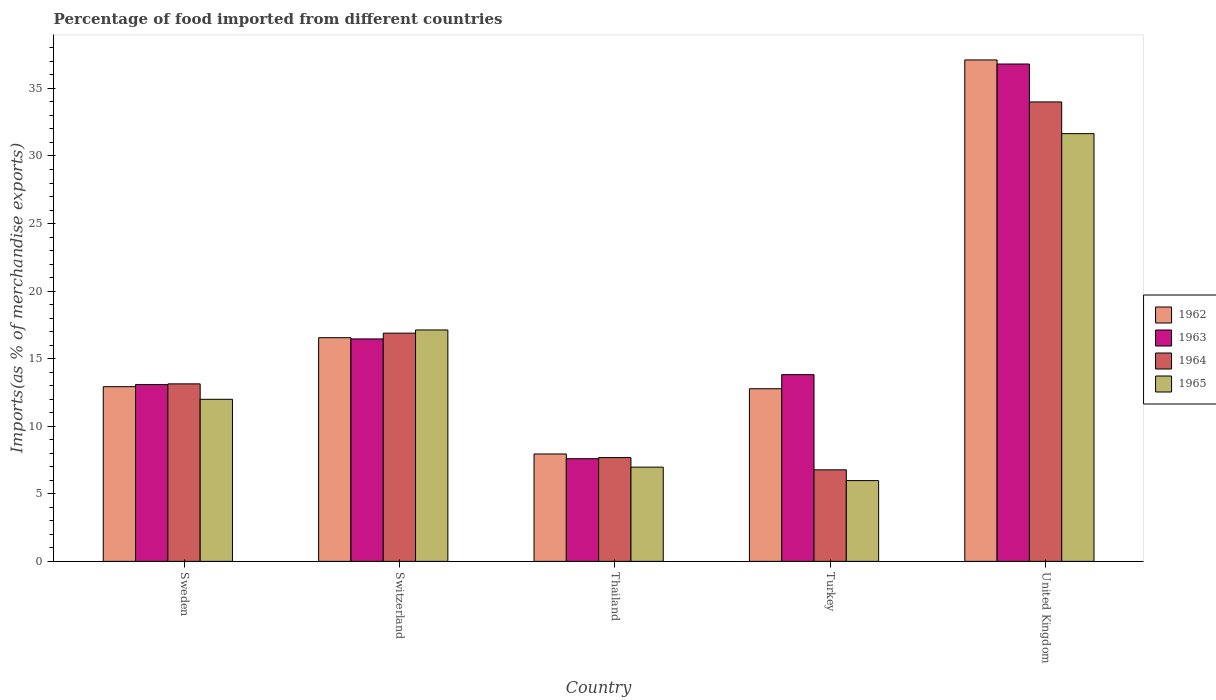How many groups of bars are there?
Ensure brevity in your answer.  5. Are the number of bars per tick equal to the number of legend labels?
Make the answer very short. Yes. Are the number of bars on each tick of the X-axis equal?
Keep it short and to the point. Yes. How many bars are there on the 4th tick from the left?
Your response must be concise. 4. What is the label of the 2nd group of bars from the left?
Your response must be concise. Switzerland. What is the percentage of imports to different countries in 1962 in United Kingdom?
Your response must be concise. 37.11. Across all countries, what is the maximum percentage of imports to different countries in 1964?
Keep it short and to the point. 34. Across all countries, what is the minimum percentage of imports to different countries in 1962?
Your answer should be compact. 7.95. In which country was the percentage of imports to different countries in 1965 minimum?
Give a very brief answer. Turkey. What is the total percentage of imports to different countries in 1963 in the graph?
Your answer should be compact. 87.77. What is the difference between the percentage of imports to different countries in 1962 in Switzerland and that in Turkey?
Your answer should be compact. 3.78. What is the difference between the percentage of imports to different countries in 1965 in United Kingdom and the percentage of imports to different countries in 1962 in Turkey?
Ensure brevity in your answer.  18.88. What is the average percentage of imports to different countries in 1962 per country?
Give a very brief answer. 17.46. What is the difference between the percentage of imports to different countries of/in 1963 and percentage of imports to different countries of/in 1965 in Thailand?
Provide a short and direct response. 0.62. What is the ratio of the percentage of imports to different countries in 1963 in Switzerland to that in United Kingdom?
Keep it short and to the point. 0.45. Is the percentage of imports to different countries in 1963 in Thailand less than that in Turkey?
Provide a succinct answer. Yes. Is the difference between the percentage of imports to different countries in 1963 in Switzerland and United Kingdom greater than the difference between the percentage of imports to different countries in 1965 in Switzerland and United Kingdom?
Give a very brief answer. No. What is the difference between the highest and the second highest percentage of imports to different countries in 1962?
Provide a short and direct response. 3.63. What is the difference between the highest and the lowest percentage of imports to different countries in 1963?
Provide a succinct answer. 29.21. What does the 4th bar from the left in Sweden represents?
Provide a short and direct response. 1965. Is it the case that in every country, the sum of the percentage of imports to different countries in 1962 and percentage of imports to different countries in 1963 is greater than the percentage of imports to different countries in 1964?
Offer a very short reply. Yes. How many bars are there?
Provide a short and direct response. 20. Are the values on the major ticks of Y-axis written in scientific E-notation?
Your answer should be very brief. No. Does the graph contain grids?
Make the answer very short. No. What is the title of the graph?
Provide a succinct answer. Percentage of food imported from different countries. What is the label or title of the Y-axis?
Provide a short and direct response. Imports(as % of merchandise exports). What is the Imports(as % of merchandise exports) of 1962 in Sweden?
Provide a short and direct response. 12.93. What is the Imports(as % of merchandise exports) in 1963 in Sweden?
Keep it short and to the point. 13.08. What is the Imports(as % of merchandise exports) in 1964 in Sweden?
Make the answer very short. 13.14. What is the Imports(as % of merchandise exports) of 1965 in Sweden?
Keep it short and to the point. 11.99. What is the Imports(as % of merchandise exports) of 1962 in Switzerland?
Your response must be concise. 16.55. What is the Imports(as % of merchandise exports) of 1963 in Switzerland?
Your answer should be compact. 16.46. What is the Imports(as % of merchandise exports) in 1964 in Switzerland?
Make the answer very short. 16.89. What is the Imports(as % of merchandise exports) of 1965 in Switzerland?
Provide a succinct answer. 17.12. What is the Imports(as % of merchandise exports) of 1962 in Thailand?
Give a very brief answer. 7.95. What is the Imports(as % of merchandise exports) of 1963 in Thailand?
Provide a succinct answer. 7.6. What is the Imports(as % of merchandise exports) in 1964 in Thailand?
Keep it short and to the point. 7.68. What is the Imports(as % of merchandise exports) in 1965 in Thailand?
Your response must be concise. 6.97. What is the Imports(as % of merchandise exports) in 1962 in Turkey?
Keep it short and to the point. 12.77. What is the Imports(as % of merchandise exports) in 1963 in Turkey?
Offer a terse response. 13.82. What is the Imports(as % of merchandise exports) in 1964 in Turkey?
Your answer should be very brief. 6.77. What is the Imports(as % of merchandise exports) in 1965 in Turkey?
Provide a short and direct response. 5.98. What is the Imports(as % of merchandise exports) of 1962 in United Kingdom?
Ensure brevity in your answer.  37.11. What is the Imports(as % of merchandise exports) of 1963 in United Kingdom?
Your answer should be very brief. 36.81. What is the Imports(as % of merchandise exports) of 1964 in United Kingdom?
Your answer should be very brief. 34. What is the Imports(as % of merchandise exports) in 1965 in United Kingdom?
Offer a terse response. 31.65. Across all countries, what is the maximum Imports(as % of merchandise exports) in 1962?
Your answer should be compact. 37.11. Across all countries, what is the maximum Imports(as % of merchandise exports) of 1963?
Make the answer very short. 36.81. Across all countries, what is the maximum Imports(as % of merchandise exports) of 1964?
Ensure brevity in your answer.  34. Across all countries, what is the maximum Imports(as % of merchandise exports) in 1965?
Make the answer very short. 31.65. Across all countries, what is the minimum Imports(as % of merchandise exports) of 1962?
Ensure brevity in your answer.  7.95. Across all countries, what is the minimum Imports(as % of merchandise exports) in 1963?
Offer a terse response. 7.6. Across all countries, what is the minimum Imports(as % of merchandise exports) of 1964?
Offer a terse response. 6.77. Across all countries, what is the minimum Imports(as % of merchandise exports) in 1965?
Provide a succinct answer. 5.98. What is the total Imports(as % of merchandise exports) in 1962 in the graph?
Offer a very short reply. 87.31. What is the total Imports(as % of merchandise exports) in 1963 in the graph?
Keep it short and to the point. 87.77. What is the total Imports(as % of merchandise exports) in 1964 in the graph?
Offer a terse response. 78.48. What is the total Imports(as % of merchandise exports) in 1965 in the graph?
Make the answer very short. 73.72. What is the difference between the Imports(as % of merchandise exports) of 1962 in Sweden and that in Switzerland?
Ensure brevity in your answer.  -3.63. What is the difference between the Imports(as % of merchandise exports) of 1963 in Sweden and that in Switzerland?
Keep it short and to the point. -3.38. What is the difference between the Imports(as % of merchandise exports) in 1964 in Sweden and that in Switzerland?
Provide a short and direct response. -3.75. What is the difference between the Imports(as % of merchandise exports) of 1965 in Sweden and that in Switzerland?
Your response must be concise. -5.13. What is the difference between the Imports(as % of merchandise exports) of 1962 in Sweden and that in Thailand?
Keep it short and to the point. 4.98. What is the difference between the Imports(as % of merchandise exports) in 1963 in Sweden and that in Thailand?
Provide a short and direct response. 5.49. What is the difference between the Imports(as % of merchandise exports) of 1964 in Sweden and that in Thailand?
Your response must be concise. 5.46. What is the difference between the Imports(as % of merchandise exports) in 1965 in Sweden and that in Thailand?
Make the answer very short. 5.02. What is the difference between the Imports(as % of merchandise exports) of 1962 in Sweden and that in Turkey?
Make the answer very short. 0.15. What is the difference between the Imports(as % of merchandise exports) of 1963 in Sweden and that in Turkey?
Offer a very short reply. -0.73. What is the difference between the Imports(as % of merchandise exports) of 1964 in Sweden and that in Turkey?
Offer a terse response. 6.36. What is the difference between the Imports(as % of merchandise exports) of 1965 in Sweden and that in Turkey?
Make the answer very short. 6.02. What is the difference between the Imports(as % of merchandise exports) of 1962 in Sweden and that in United Kingdom?
Offer a terse response. -24.18. What is the difference between the Imports(as % of merchandise exports) of 1963 in Sweden and that in United Kingdom?
Provide a short and direct response. -23.72. What is the difference between the Imports(as % of merchandise exports) of 1964 in Sweden and that in United Kingdom?
Offer a terse response. -20.86. What is the difference between the Imports(as % of merchandise exports) in 1965 in Sweden and that in United Kingdom?
Your response must be concise. -19.66. What is the difference between the Imports(as % of merchandise exports) in 1962 in Switzerland and that in Thailand?
Provide a succinct answer. 8.61. What is the difference between the Imports(as % of merchandise exports) in 1963 in Switzerland and that in Thailand?
Your answer should be compact. 8.86. What is the difference between the Imports(as % of merchandise exports) in 1964 in Switzerland and that in Thailand?
Your response must be concise. 9.21. What is the difference between the Imports(as % of merchandise exports) of 1965 in Switzerland and that in Thailand?
Your answer should be compact. 10.15. What is the difference between the Imports(as % of merchandise exports) in 1962 in Switzerland and that in Turkey?
Keep it short and to the point. 3.78. What is the difference between the Imports(as % of merchandise exports) in 1963 in Switzerland and that in Turkey?
Offer a very short reply. 2.64. What is the difference between the Imports(as % of merchandise exports) of 1964 in Switzerland and that in Turkey?
Provide a succinct answer. 10.11. What is the difference between the Imports(as % of merchandise exports) in 1965 in Switzerland and that in Turkey?
Keep it short and to the point. 11.15. What is the difference between the Imports(as % of merchandise exports) of 1962 in Switzerland and that in United Kingdom?
Give a very brief answer. -20.56. What is the difference between the Imports(as % of merchandise exports) in 1963 in Switzerland and that in United Kingdom?
Your response must be concise. -20.35. What is the difference between the Imports(as % of merchandise exports) of 1964 in Switzerland and that in United Kingdom?
Offer a very short reply. -17.11. What is the difference between the Imports(as % of merchandise exports) of 1965 in Switzerland and that in United Kingdom?
Give a very brief answer. -14.53. What is the difference between the Imports(as % of merchandise exports) of 1962 in Thailand and that in Turkey?
Keep it short and to the point. -4.83. What is the difference between the Imports(as % of merchandise exports) in 1963 in Thailand and that in Turkey?
Your answer should be very brief. -6.22. What is the difference between the Imports(as % of merchandise exports) of 1964 in Thailand and that in Turkey?
Ensure brevity in your answer.  0.91. What is the difference between the Imports(as % of merchandise exports) in 1962 in Thailand and that in United Kingdom?
Make the answer very short. -29.16. What is the difference between the Imports(as % of merchandise exports) of 1963 in Thailand and that in United Kingdom?
Provide a short and direct response. -29.21. What is the difference between the Imports(as % of merchandise exports) of 1964 in Thailand and that in United Kingdom?
Offer a terse response. -26.32. What is the difference between the Imports(as % of merchandise exports) of 1965 in Thailand and that in United Kingdom?
Ensure brevity in your answer.  -24.68. What is the difference between the Imports(as % of merchandise exports) of 1962 in Turkey and that in United Kingdom?
Your answer should be very brief. -24.33. What is the difference between the Imports(as % of merchandise exports) of 1963 in Turkey and that in United Kingdom?
Your answer should be compact. -22.99. What is the difference between the Imports(as % of merchandise exports) in 1964 in Turkey and that in United Kingdom?
Make the answer very short. -27.23. What is the difference between the Imports(as % of merchandise exports) of 1965 in Turkey and that in United Kingdom?
Provide a short and direct response. -25.68. What is the difference between the Imports(as % of merchandise exports) of 1962 in Sweden and the Imports(as % of merchandise exports) of 1963 in Switzerland?
Keep it short and to the point. -3.53. What is the difference between the Imports(as % of merchandise exports) of 1962 in Sweden and the Imports(as % of merchandise exports) of 1964 in Switzerland?
Offer a terse response. -3.96. What is the difference between the Imports(as % of merchandise exports) of 1962 in Sweden and the Imports(as % of merchandise exports) of 1965 in Switzerland?
Ensure brevity in your answer.  -4.2. What is the difference between the Imports(as % of merchandise exports) of 1963 in Sweden and the Imports(as % of merchandise exports) of 1964 in Switzerland?
Provide a short and direct response. -3.81. What is the difference between the Imports(as % of merchandise exports) in 1963 in Sweden and the Imports(as % of merchandise exports) in 1965 in Switzerland?
Offer a very short reply. -4.04. What is the difference between the Imports(as % of merchandise exports) in 1964 in Sweden and the Imports(as % of merchandise exports) in 1965 in Switzerland?
Give a very brief answer. -3.99. What is the difference between the Imports(as % of merchandise exports) of 1962 in Sweden and the Imports(as % of merchandise exports) of 1963 in Thailand?
Give a very brief answer. 5.33. What is the difference between the Imports(as % of merchandise exports) of 1962 in Sweden and the Imports(as % of merchandise exports) of 1964 in Thailand?
Your answer should be very brief. 5.25. What is the difference between the Imports(as % of merchandise exports) of 1962 in Sweden and the Imports(as % of merchandise exports) of 1965 in Thailand?
Your answer should be compact. 5.95. What is the difference between the Imports(as % of merchandise exports) of 1963 in Sweden and the Imports(as % of merchandise exports) of 1964 in Thailand?
Ensure brevity in your answer.  5.4. What is the difference between the Imports(as % of merchandise exports) in 1963 in Sweden and the Imports(as % of merchandise exports) in 1965 in Thailand?
Make the answer very short. 6.11. What is the difference between the Imports(as % of merchandise exports) of 1964 in Sweden and the Imports(as % of merchandise exports) of 1965 in Thailand?
Provide a succinct answer. 6.16. What is the difference between the Imports(as % of merchandise exports) in 1962 in Sweden and the Imports(as % of merchandise exports) in 1963 in Turkey?
Ensure brevity in your answer.  -0.89. What is the difference between the Imports(as % of merchandise exports) of 1962 in Sweden and the Imports(as % of merchandise exports) of 1964 in Turkey?
Your response must be concise. 6.15. What is the difference between the Imports(as % of merchandise exports) of 1962 in Sweden and the Imports(as % of merchandise exports) of 1965 in Turkey?
Your answer should be compact. 6.95. What is the difference between the Imports(as % of merchandise exports) in 1963 in Sweden and the Imports(as % of merchandise exports) in 1964 in Turkey?
Keep it short and to the point. 6.31. What is the difference between the Imports(as % of merchandise exports) in 1963 in Sweden and the Imports(as % of merchandise exports) in 1965 in Turkey?
Your answer should be compact. 7.11. What is the difference between the Imports(as % of merchandise exports) of 1964 in Sweden and the Imports(as % of merchandise exports) of 1965 in Turkey?
Your answer should be very brief. 7.16. What is the difference between the Imports(as % of merchandise exports) in 1962 in Sweden and the Imports(as % of merchandise exports) in 1963 in United Kingdom?
Your answer should be very brief. -23.88. What is the difference between the Imports(as % of merchandise exports) in 1962 in Sweden and the Imports(as % of merchandise exports) in 1964 in United Kingdom?
Your answer should be compact. -21.07. What is the difference between the Imports(as % of merchandise exports) of 1962 in Sweden and the Imports(as % of merchandise exports) of 1965 in United Kingdom?
Your answer should be compact. -18.73. What is the difference between the Imports(as % of merchandise exports) of 1963 in Sweden and the Imports(as % of merchandise exports) of 1964 in United Kingdom?
Your response must be concise. -20.92. What is the difference between the Imports(as % of merchandise exports) of 1963 in Sweden and the Imports(as % of merchandise exports) of 1965 in United Kingdom?
Provide a short and direct response. -18.57. What is the difference between the Imports(as % of merchandise exports) of 1964 in Sweden and the Imports(as % of merchandise exports) of 1965 in United Kingdom?
Ensure brevity in your answer.  -18.52. What is the difference between the Imports(as % of merchandise exports) of 1962 in Switzerland and the Imports(as % of merchandise exports) of 1963 in Thailand?
Ensure brevity in your answer.  8.96. What is the difference between the Imports(as % of merchandise exports) of 1962 in Switzerland and the Imports(as % of merchandise exports) of 1964 in Thailand?
Ensure brevity in your answer.  8.87. What is the difference between the Imports(as % of merchandise exports) of 1962 in Switzerland and the Imports(as % of merchandise exports) of 1965 in Thailand?
Offer a terse response. 9.58. What is the difference between the Imports(as % of merchandise exports) of 1963 in Switzerland and the Imports(as % of merchandise exports) of 1964 in Thailand?
Your response must be concise. 8.78. What is the difference between the Imports(as % of merchandise exports) in 1963 in Switzerland and the Imports(as % of merchandise exports) in 1965 in Thailand?
Give a very brief answer. 9.49. What is the difference between the Imports(as % of merchandise exports) of 1964 in Switzerland and the Imports(as % of merchandise exports) of 1965 in Thailand?
Your answer should be very brief. 9.92. What is the difference between the Imports(as % of merchandise exports) of 1962 in Switzerland and the Imports(as % of merchandise exports) of 1963 in Turkey?
Give a very brief answer. 2.74. What is the difference between the Imports(as % of merchandise exports) in 1962 in Switzerland and the Imports(as % of merchandise exports) in 1964 in Turkey?
Give a very brief answer. 9.78. What is the difference between the Imports(as % of merchandise exports) in 1962 in Switzerland and the Imports(as % of merchandise exports) in 1965 in Turkey?
Provide a succinct answer. 10.58. What is the difference between the Imports(as % of merchandise exports) of 1963 in Switzerland and the Imports(as % of merchandise exports) of 1964 in Turkey?
Offer a very short reply. 9.69. What is the difference between the Imports(as % of merchandise exports) of 1963 in Switzerland and the Imports(as % of merchandise exports) of 1965 in Turkey?
Give a very brief answer. 10.48. What is the difference between the Imports(as % of merchandise exports) in 1964 in Switzerland and the Imports(as % of merchandise exports) in 1965 in Turkey?
Offer a very short reply. 10.91. What is the difference between the Imports(as % of merchandise exports) in 1962 in Switzerland and the Imports(as % of merchandise exports) in 1963 in United Kingdom?
Provide a short and direct response. -20.25. What is the difference between the Imports(as % of merchandise exports) of 1962 in Switzerland and the Imports(as % of merchandise exports) of 1964 in United Kingdom?
Offer a terse response. -17.45. What is the difference between the Imports(as % of merchandise exports) in 1962 in Switzerland and the Imports(as % of merchandise exports) in 1965 in United Kingdom?
Your response must be concise. -15.1. What is the difference between the Imports(as % of merchandise exports) of 1963 in Switzerland and the Imports(as % of merchandise exports) of 1964 in United Kingdom?
Give a very brief answer. -17.54. What is the difference between the Imports(as % of merchandise exports) in 1963 in Switzerland and the Imports(as % of merchandise exports) in 1965 in United Kingdom?
Offer a very short reply. -15.19. What is the difference between the Imports(as % of merchandise exports) of 1964 in Switzerland and the Imports(as % of merchandise exports) of 1965 in United Kingdom?
Your answer should be compact. -14.77. What is the difference between the Imports(as % of merchandise exports) of 1962 in Thailand and the Imports(as % of merchandise exports) of 1963 in Turkey?
Make the answer very short. -5.87. What is the difference between the Imports(as % of merchandise exports) of 1962 in Thailand and the Imports(as % of merchandise exports) of 1964 in Turkey?
Make the answer very short. 1.17. What is the difference between the Imports(as % of merchandise exports) of 1962 in Thailand and the Imports(as % of merchandise exports) of 1965 in Turkey?
Ensure brevity in your answer.  1.97. What is the difference between the Imports(as % of merchandise exports) of 1963 in Thailand and the Imports(as % of merchandise exports) of 1964 in Turkey?
Your response must be concise. 0.82. What is the difference between the Imports(as % of merchandise exports) in 1963 in Thailand and the Imports(as % of merchandise exports) in 1965 in Turkey?
Ensure brevity in your answer.  1.62. What is the difference between the Imports(as % of merchandise exports) in 1964 in Thailand and the Imports(as % of merchandise exports) in 1965 in Turkey?
Your answer should be compact. 1.7. What is the difference between the Imports(as % of merchandise exports) of 1962 in Thailand and the Imports(as % of merchandise exports) of 1963 in United Kingdom?
Provide a short and direct response. -28.86. What is the difference between the Imports(as % of merchandise exports) in 1962 in Thailand and the Imports(as % of merchandise exports) in 1964 in United Kingdom?
Give a very brief answer. -26.05. What is the difference between the Imports(as % of merchandise exports) of 1962 in Thailand and the Imports(as % of merchandise exports) of 1965 in United Kingdom?
Give a very brief answer. -23.71. What is the difference between the Imports(as % of merchandise exports) of 1963 in Thailand and the Imports(as % of merchandise exports) of 1964 in United Kingdom?
Offer a very short reply. -26.4. What is the difference between the Imports(as % of merchandise exports) of 1963 in Thailand and the Imports(as % of merchandise exports) of 1965 in United Kingdom?
Offer a terse response. -24.06. What is the difference between the Imports(as % of merchandise exports) of 1964 in Thailand and the Imports(as % of merchandise exports) of 1965 in United Kingdom?
Provide a short and direct response. -23.97. What is the difference between the Imports(as % of merchandise exports) in 1962 in Turkey and the Imports(as % of merchandise exports) in 1963 in United Kingdom?
Offer a very short reply. -24.03. What is the difference between the Imports(as % of merchandise exports) of 1962 in Turkey and the Imports(as % of merchandise exports) of 1964 in United Kingdom?
Provide a succinct answer. -21.23. What is the difference between the Imports(as % of merchandise exports) in 1962 in Turkey and the Imports(as % of merchandise exports) in 1965 in United Kingdom?
Give a very brief answer. -18.88. What is the difference between the Imports(as % of merchandise exports) of 1963 in Turkey and the Imports(as % of merchandise exports) of 1964 in United Kingdom?
Ensure brevity in your answer.  -20.18. What is the difference between the Imports(as % of merchandise exports) of 1963 in Turkey and the Imports(as % of merchandise exports) of 1965 in United Kingdom?
Your response must be concise. -17.84. What is the difference between the Imports(as % of merchandise exports) of 1964 in Turkey and the Imports(as % of merchandise exports) of 1965 in United Kingdom?
Provide a succinct answer. -24.88. What is the average Imports(as % of merchandise exports) in 1962 per country?
Your response must be concise. 17.46. What is the average Imports(as % of merchandise exports) of 1963 per country?
Your answer should be compact. 17.55. What is the average Imports(as % of merchandise exports) in 1964 per country?
Provide a succinct answer. 15.7. What is the average Imports(as % of merchandise exports) of 1965 per country?
Your response must be concise. 14.74. What is the difference between the Imports(as % of merchandise exports) of 1962 and Imports(as % of merchandise exports) of 1963 in Sweden?
Provide a short and direct response. -0.16. What is the difference between the Imports(as % of merchandise exports) of 1962 and Imports(as % of merchandise exports) of 1964 in Sweden?
Make the answer very short. -0.21. What is the difference between the Imports(as % of merchandise exports) in 1962 and Imports(as % of merchandise exports) in 1965 in Sweden?
Your answer should be compact. 0.93. What is the difference between the Imports(as % of merchandise exports) in 1963 and Imports(as % of merchandise exports) in 1964 in Sweden?
Provide a short and direct response. -0.05. What is the difference between the Imports(as % of merchandise exports) of 1963 and Imports(as % of merchandise exports) of 1965 in Sweden?
Give a very brief answer. 1.09. What is the difference between the Imports(as % of merchandise exports) in 1964 and Imports(as % of merchandise exports) in 1965 in Sweden?
Ensure brevity in your answer.  1.14. What is the difference between the Imports(as % of merchandise exports) of 1962 and Imports(as % of merchandise exports) of 1963 in Switzerland?
Ensure brevity in your answer.  0.09. What is the difference between the Imports(as % of merchandise exports) of 1962 and Imports(as % of merchandise exports) of 1964 in Switzerland?
Give a very brief answer. -0.34. What is the difference between the Imports(as % of merchandise exports) in 1962 and Imports(as % of merchandise exports) in 1965 in Switzerland?
Your answer should be compact. -0.57. What is the difference between the Imports(as % of merchandise exports) of 1963 and Imports(as % of merchandise exports) of 1964 in Switzerland?
Make the answer very short. -0.43. What is the difference between the Imports(as % of merchandise exports) in 1963 and Imports(as % of merchandise exports) in 1965 in Switzerland?
Keep it short and to the point. -0.66. What is the difference between the Imports(as % of merchandise exports) in 1964 and Imports(as % of merchandise exports) in 1965 in Switzerland?
Ensure brevity in your answer.  -0.24. What is the difference between the Imports(as % of merchandise exports) in 1962 and Imports(as % of merchandise exports) in 1963 in Thailand?
Give a very brief answer. 0.35. What is the difference between the Imports(as % of merchandise exports) in 1962 and Imports(as % of merchandise exports) in 1964 in Thailand?
Keep it short and to the point. 0.27. What is the difference between the Imports(as % of merchandise exports) in 1962 and Imports(as % of merchandise exports) in 1965 in Thailand?
Provide a short and direct response. 0.97. What is the difference between the Imports(as % of merchandise exports) in 1963 and Imports(as % of merchandise exports) in 1964 in Thailand?
Offer a very short reply. -0.08. What is the difference between the Imports(as % of merchandise exports) of 1963 and Imports(as % of merchandise exports) of 1965 in Thailand?
Offer a very short reply. 0.62. What is the difference between the Imports(as % of merchandise exports) in 1964 and Imports(as % of merchandise exports) in 1965 in Thailand?
Keep it short and to the point. 0.71. What is the difference between the Imports(as % of merchandise exports) of 1962 and Imports(as % of merchandise exports) of 1963 in Turkey?
Your answer should be compact. -1.04. What is the difference between the Imports(as % of merchandise exports) of 1962 and Imports(as % of merchandise exports) of 1964 in Turkey?
Offer a very short reply. 6. What is the difference between the Imports(as % of merchandise exports) in 1962 and Imports(as % of merchandise exports) in 1965 in Turkey?
Give a very brief answer. 6.8. What is the difference between the Imports(as % of merchandise exports) in 1963 and Imports(as % of merchandise exports) in 1964 in Turkey?
Offer a very short reply. 7.04. What is the difference between the Imports(as % of merchandise exports) in 1963 and Imports(as % of merchandise exports) in 1965 in Turkey?
Give a very brief answer. 7.84. What is the difference between the Imports(as % of merchandise exports) in 1964 and Imports(as % of merchandise exports) in 1965 in Turkey?
Provide a short and direct response. 0.8. What is the difference between the Imports(as % of merchandise exports) of 1962 and Imports(as % of merchandise exports) of 1963 in United Kingdom?
Your answer should be compact. 0.3. What is the difference between the Imports(as % of merchandise exports) of 1962 and Imports(as % of merchandise exports) of 1964 in United Kingdom?
Keep it short and to the point. 3.11. What is the difference between the Imports(as % of merchandise exports) in 1962 and Imports(as % of merchandise exports) in 1965 in United Kingdom?
Your answer should be compact. 5.45. What is the difference between the Imports(as % of merchandise exports) in 1963 and Imports(as % of merchandise exports) in 1964 in United Kingdom?
Make the answer very short. 2.81. What is the difference between the Imports(as % of merchandise exports) in 1963 and Imports(as % of merchandise exports) in 1965 in United Kingdom?
Keep it short and to the point. 5.15. What is the difference between the Imports(as % of merchandise exports) of 1964 and Imports(as % of merchandise exports) of 1965 in United Kingdom?
Ensure brevity in your answer.  2.35. What is the ratio of the Imports(as % of merchandise exports) of 1962 in Sweden to that in Switzerland?
Your answer should be compact. 0.78. What is the ratio of the Imports(as % of merchandise exports) in 1963 in Sweden to that in Switzerland?
Your answer should be compact. 0.79. What is the ratio of the Imports(as % of merchandise exports) of 1965 in Sweden to that in Switzerland?
Your answer should be compact. 0.7. What is the ratio of the Imports(as % of merchandise exports) in 1962 in Sweden to that in Thailand?
Provide a short and direct response. 1.63. What is the ratio of the Imports(as % of merchandise exports) in 1963 in Sweden to that in Thailand?
Offer a very short reply. 1.72. What is the ratio of the Imports(as % of merchandise exports) of 1964 in Sweden to that in Thailand?
Keep it short and to the point. 1.71. What is the ratio of the Imports(as % of merchandise exports) of 1965 in Sweden to that in Thailand?
Your response must be concise. 1.72. What is the ratio of the Imports(as % of merchandise exports) in 1962 in Sweden to that in Turkey?
Make the answer very short. 1.01. What is the ratio of the Imports(as % of merchandise exports) in 1963 in Sweden to that in Turkey?
Ensure brevity in your answer.  0.95. What is the ratio of the Imports(as % of merchandise exports) of 1964 in Sweden to that in Turkey?
Your answer should be compact. 1.94. What is the ratio of the Imports(as % of merchandise exports) in 1965 in Sweden to that in Turkey?
Your answer should be compact. 2.01. What is the ratio of the Imports(as % of merchandise exports) in 1962 in Sweden to that in United Kingdom?
Provide a succinct answer. 0.35. What is the ratio of the Imports(as % of merchandise exports) of 1963 in Sweden to that in United Kingdom?
Give a very brief answer. 0.36. What is the ratio of the Imports(as % of merchandise exports) of 1964 in Sweden to that in United Kingdom?
Give a very brief answer. 0.39. What is the ratio of the Imports(as % of merchandise exports) in 1965 in Sweden to that in United Kingdom?
Offer a terse response. 0.38. What is the ratio of the Imports(as % of merchandise exports) in 1962 in Switzerland to that in Thailand?
Provide a short and direct response. 2.08. What is the ratio of the Imports(as % of merchandise exports) of 1963 in Switzerland to that in Thailand?
Offer a terse response. 2.17. What is the ratio of the Imports(as % of merchandise exports) in 1964 in Switzerland to that in Thailand?
Offer a very short reply. 2.2. What is the ratio of the Imports(as % of merchandise exports) in 1965 in Switzerland to that in Thailand?
Give a very brief answer. 2.46. What is the ratio of the Imports(as % of merchandise exports) in 1962 in Switzerland to that in Turkey?
Offer a terse response. 1.3. What is the ratio of the Imports(as % of merchandise exports) in 1963 in Switzerland to that in Turkey?
Keep it short and to the point. 1.19. What is the ratio of the Imports(as % of merchandise exports) in 1964 in Switzerland to that in Turkey?
Your response must be concise. 2.49. What is the ratio of the Imports(as % of merchandise exports) of 1965 in Switzerland to that in Turkey?
Keep it short and to the point. 2.87. What is the ratio of the Imports(as % of merchandise exports) in 1962 in Switzerland to that in United Kingdom?
Your answer should be very brief. 0.45. What is the ratio of the Imports(as % of merchandise exports) of 1963 in Switzerland to that in United Kingdom?
Your response must be concise. 0.45. What is the ratio of the Imports(as % of merchandise exports) in 1964 in Switzerland to that in United Kingdom?
Provide a succinct answer. 0.5. What is the ratio of the Imports(as % of merchandise exports) of 1965 in Switzerland to that in United Kingdom?
Your response must be concise. 0.54. What is the ratio of the Imports(as % of merchandise exports) of 1962 in Thailand to that in Turkey?
Offer a very short reply. 0.62. What is the ratio of the Imports(as % of merchandise exports) of 1963 in Thailand to that in Turkey?
Your answer should be compact. 0.55. What is the ratio of the Imports(as % of merchandise exports) of 1964 in Thailand to that in Turkey?
Offer a terse response. 1.13. What is the ratio of the Imports(as % of merchandise exports) of 1965 in Thailand to that in Turkey?
Your answer should be compact. 1.17. What is the ratio of the Imports(as % of merchandise exports) of 1962 in Thailand to that in United Kingdom?
Your answer should be compact. 0.21. What is the ratio of the Imports(as % of merchandise exports) of 1963 in Thailand to that in United Kingdom?
Provide a short and direct response. 0.21. What is the ratio of the Imports(as % of merchandise exports) of 1964 in Thailand to that in United Kingdom?
Your answer should be very brief. 0.23. What is the ratio of the Imports(as % of merchandise exports) in 1965 in Thailand to that in United Kingdom?
Offer a very short reply. 0.22. What is the ratio of the Imports(as % of merchandise exports) of 1962 in Turkey to that in United Kingdom?
Your answer should be compact. 0.34. What is the ratio of the Imports(as % of merchandise exports) of 1963 in Turkey to that in United Kingdom?
Ensure brevity in your answer.  0.38. What is the ratio of the Imports(as % of merchandise exports) of 1964 in Turkey to that in United Kingdom?
Ensure brevity in your answer.  0.2. What is the ratio of the Imports(as % of merchandise exports) of 1965 in Turkey to that in United Kingdom?
Give a very brief answer. 0.19. What is the difference between the highest and the second highest Imports(as % of merchandise exports) of 1962?
Your response must be concise. 20.56. What is the difference between the highest and the second highest Imports(as % of merchandise exports) in 1963?
Provide a short and direct response. 20.35. What is the difference between the highest and the second highest Imports(as % of merchandise exports) of 1964?
Ensure brevity in your answer.  17.11. What is the difference between the highest and the second highest Imports(as % of merchandise exports) in 1965?
Your response must be concise. 14.53. What is the difference between the highest and the lowest Imports(as % of merchandise exports) in 1962?
Keep it short and to the point. 29.16. What is the difference between the highest and the lowest Imports(as % of merchandise exports) in 1963?
Your answer should be compact. 29.21. What is the difference between the highest and the lowest Imports(as % of merchandise exports) in 1964?
Ensure brevity in your answer.  27.23. What is the difference between the highest and the lowest Imports(as % of merchandise exports) in 1965?
Your answer should be compact. 25.68. 